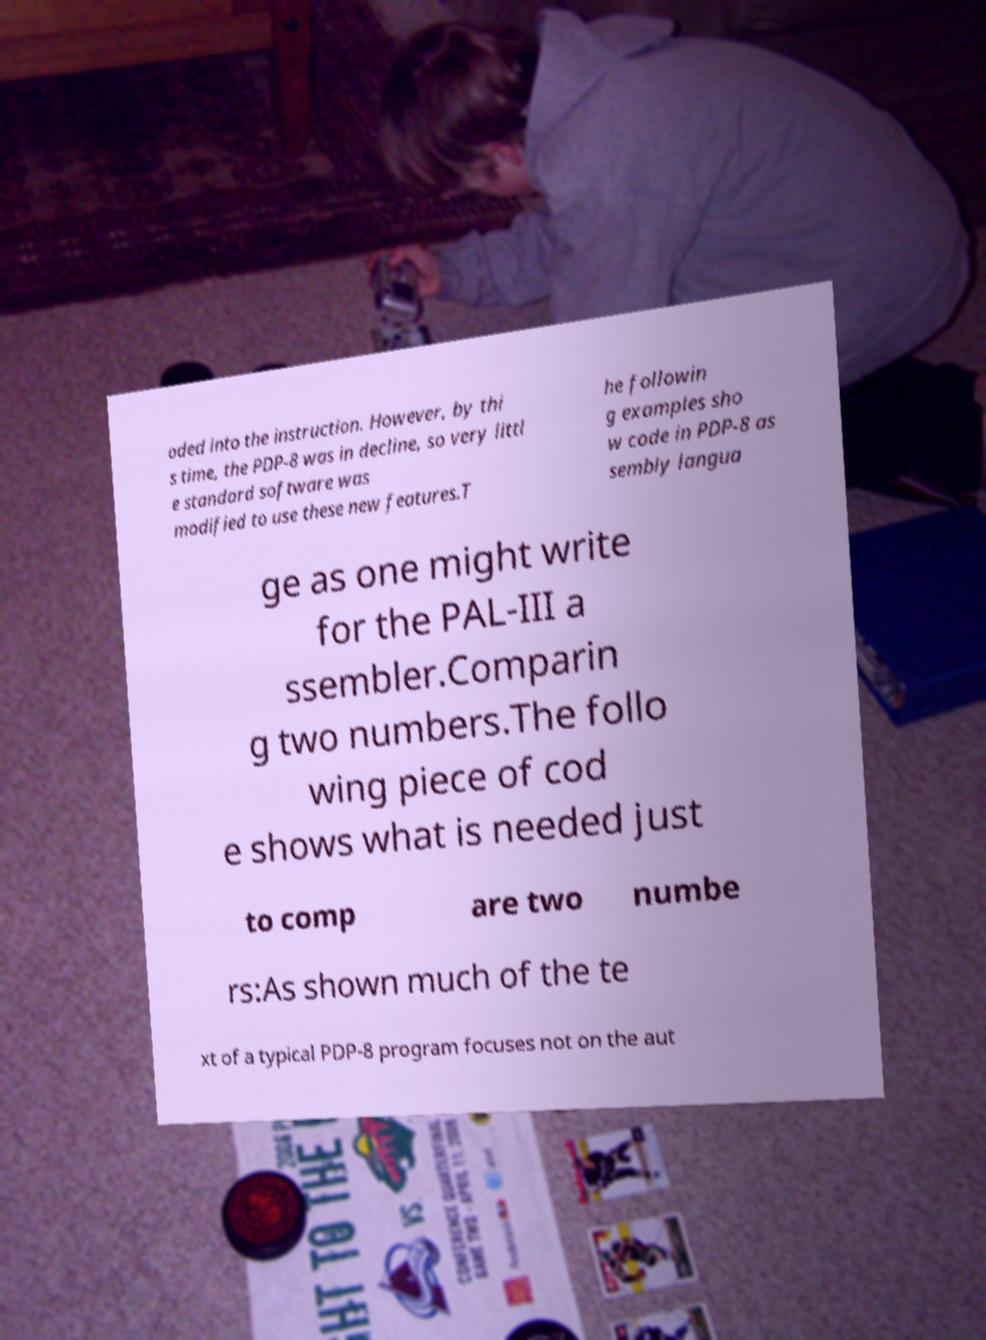Please read and relay the text visible in this image. What does it say? oded into the instruction. However, by thi s time, the PDP-8 was in decline, so very littl e standard software was modified to use these new features.T he followin g examples sho w code in PDP-8 as sembly langua ge as one might write for the PAL-III a ssembler.Comparin g two numbers.The follo wing piece of cod e shows what is needed just to comp are two numbe rs:As shown much of the te xt of a typical PDP-8 program focuses not on the aut 